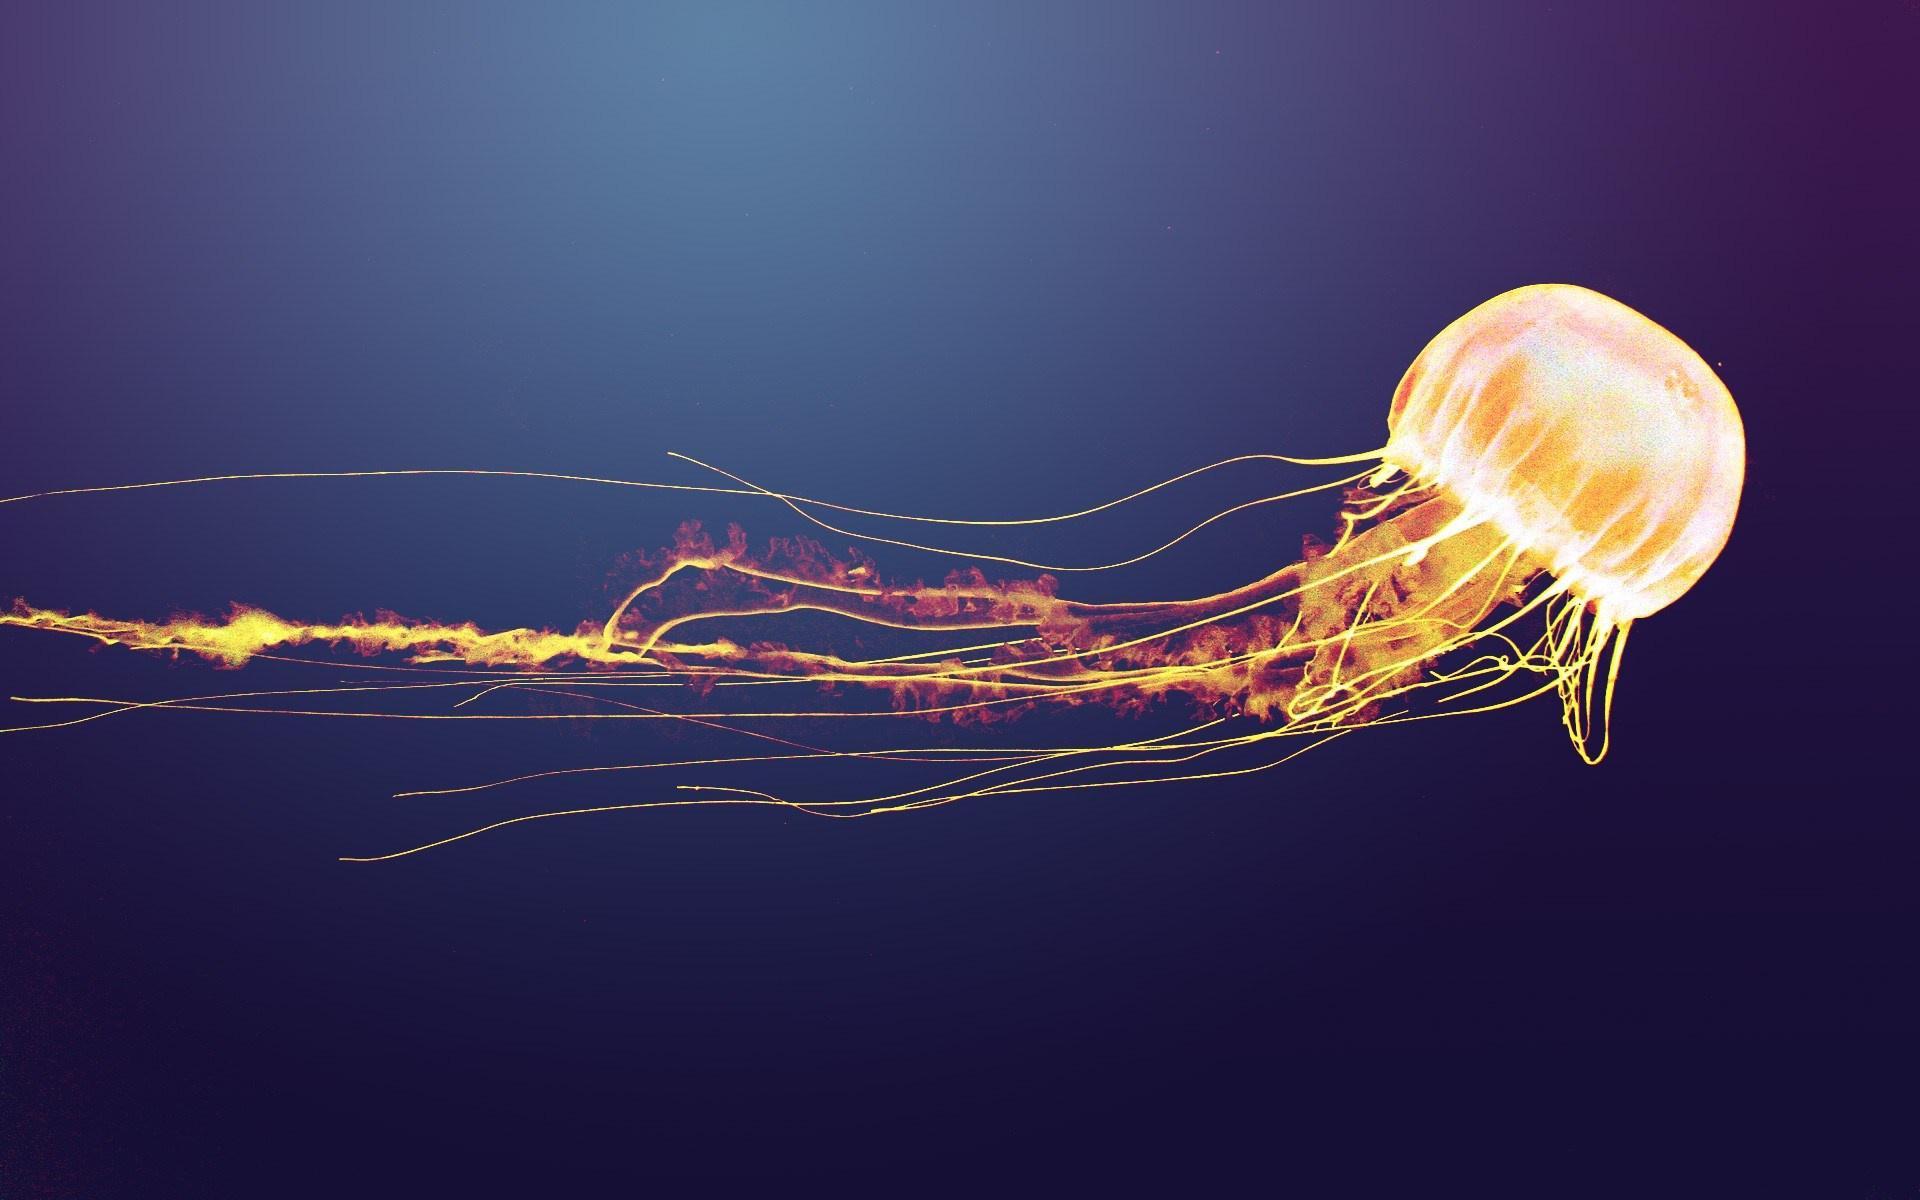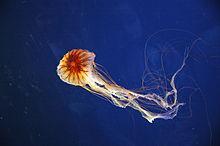The first image is the image on the left, the second image is the image on the right. Assess this claim about the two images: "Exactly two orange jellyfish are swimming through the water, one of them toward the right and the other one toward the left.". Correct or not? Answer yes or no. Yes. The first image is the image on the left, the second image is the image on the right. For the images displayed, is the sentence "in the image pair the jelly fish are facing each other" factually correct? Answer yes or no. Yes. 